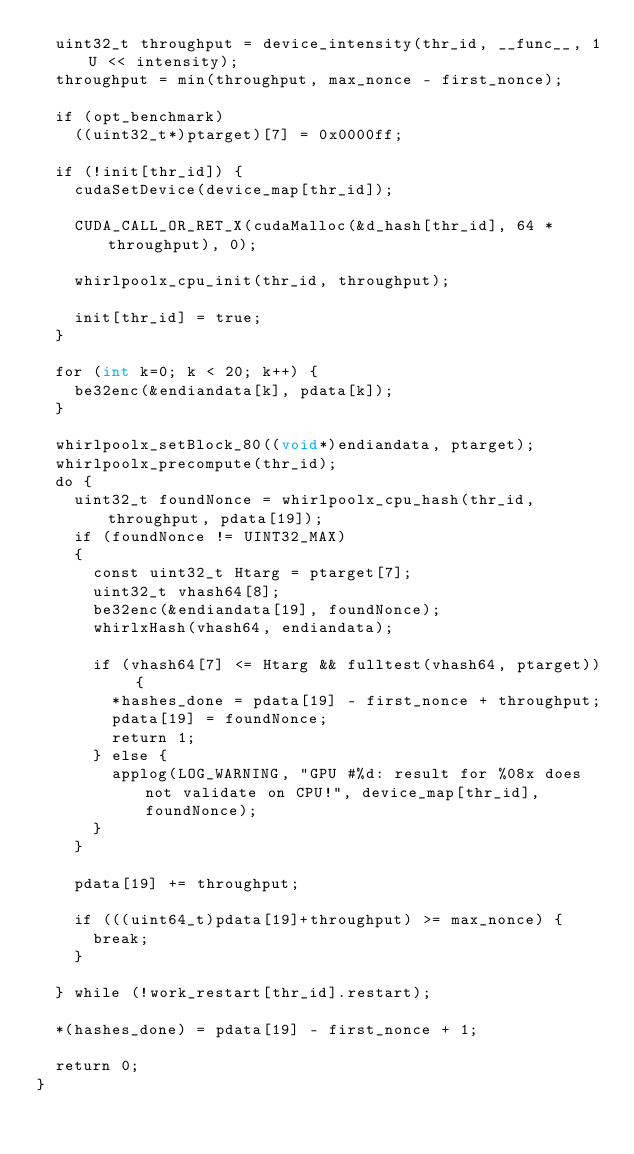Convert code to text. <code><loc_0><loc_0><loc_500><loc_500><_Cuda_>	uint32_t throughput = device_intensity(thr_id, __func__, 1U << intensity);
	throughput = min(throughput, max_nonce - first_nonce);

	if (opt_benchmark)
		((uint32_t*)ptarget)[7] = 0x0000ff;

	if (!init[thr_id]) {
		cudaSetDevice(device_map[thr_id]);

		CUDA_CALL_OR_RET_X(cudaMalloc(&d_hash[thr_id], 64 * throughput), 0);

		whirlpoolx_cpu_init(thr_id, throughput);

		init[thr_id] = true;
	}

	for (int k=0; k < 20; k++) {
		be32enc(&endiandata[k], pdata[k]);
	}

	whirlpoolx_setBlock_80((void*)endiandata, ptarget);
	whirlpoolx_precompute(thr_id);
	do {
		uint32_t foundNonce = whirlpoolx_cpu_hash(thr_id, throughput, pdata[19]);
		if (foundNonce != UINT32_MAX)
		{
			const uint32_t Htarg = ptarget[7];
			uint32_t vhash64[8];
			be32enc(&endiandata[19], foundNonce);
			whirlxHash(vhash64, endiandata);

			if (vhash64[7] <= Htarg && fulltest(vhash64, ptarget)) {
				*hashes_done = pdata[19] - first_nonce + throughput;
				pdata[19] = foundNonce;
				return 1;
			} else {
				applog(LOG_WARNING, "GPU #%d: result for %08x does not validate on CPU!", device_map[thr_id], foundNonce);
			}
		}

		pdata[19] += throughput;

		if (((uint64_t)pdata[19]+throughput) >= max_nonce) {
			break;
		}

	} while (!work_restart[thr_id].restart);

	*(hashes_done) = pdata[19] - first_nonce + 1;

	return 0;
}
</code> 